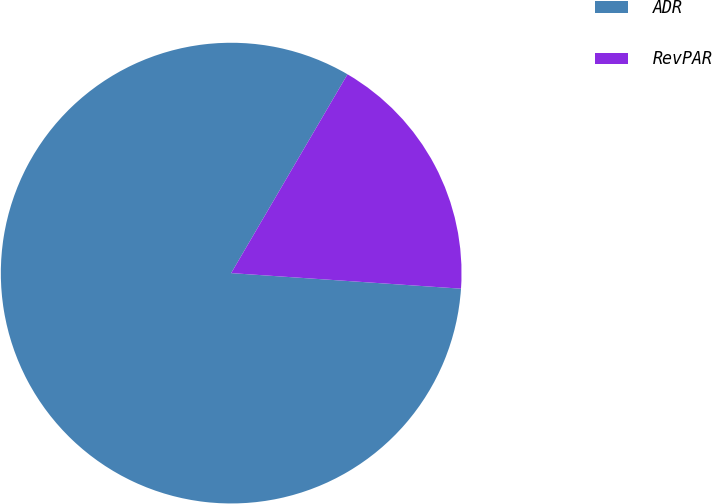<chart> <loc_0><loc_0><loc_500><loc_500><pie_chart><fcel>ADR<fcel>RevPAR<nl><fcel>82.35%<fcel>17.65%<nl></chart> 